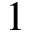<formula> <loc_0><loc_0><loc_500><loc_500>1</formula> 